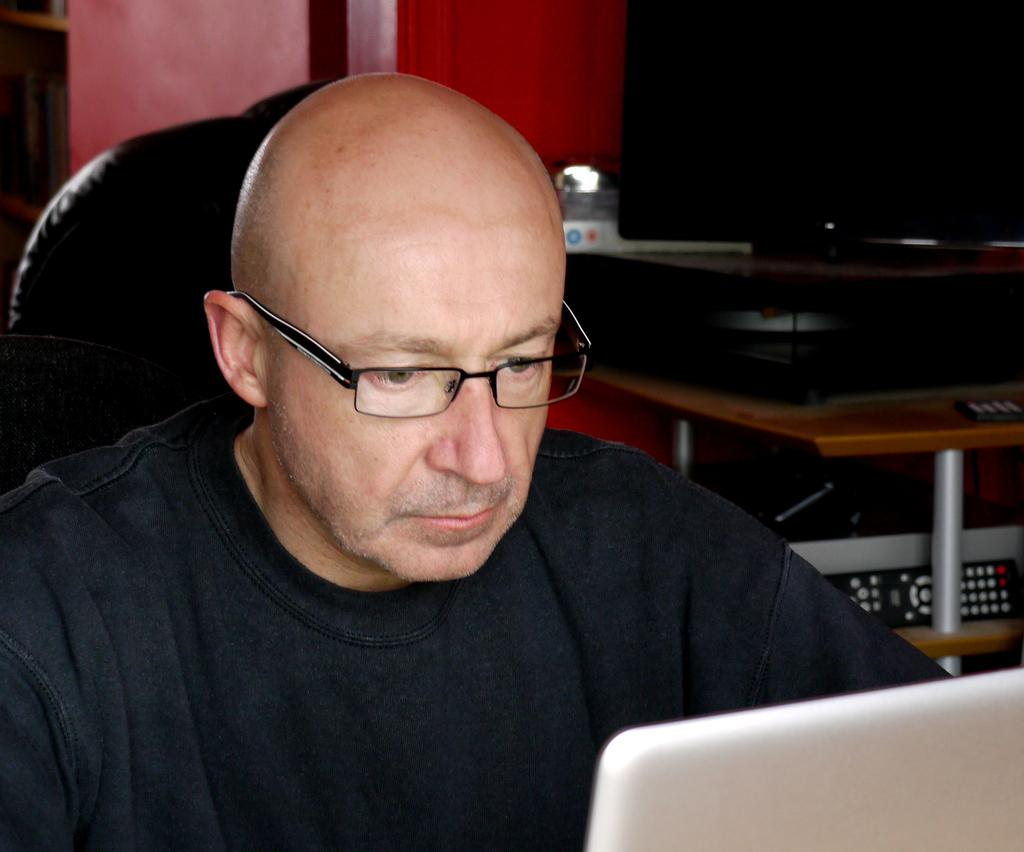What is the person in the image wearing? The person in the image is wearing a black dress. What can be seen in the background of the image? There is a television, a remote control, and objects on a rack in the background. What electronic device is visible in the image? There is a laptop visible in the image. What type of metal is the squirrel using to level the objects on the rack in the image? There is no squirrel present in the image, and therefore no such activity can be observed. 